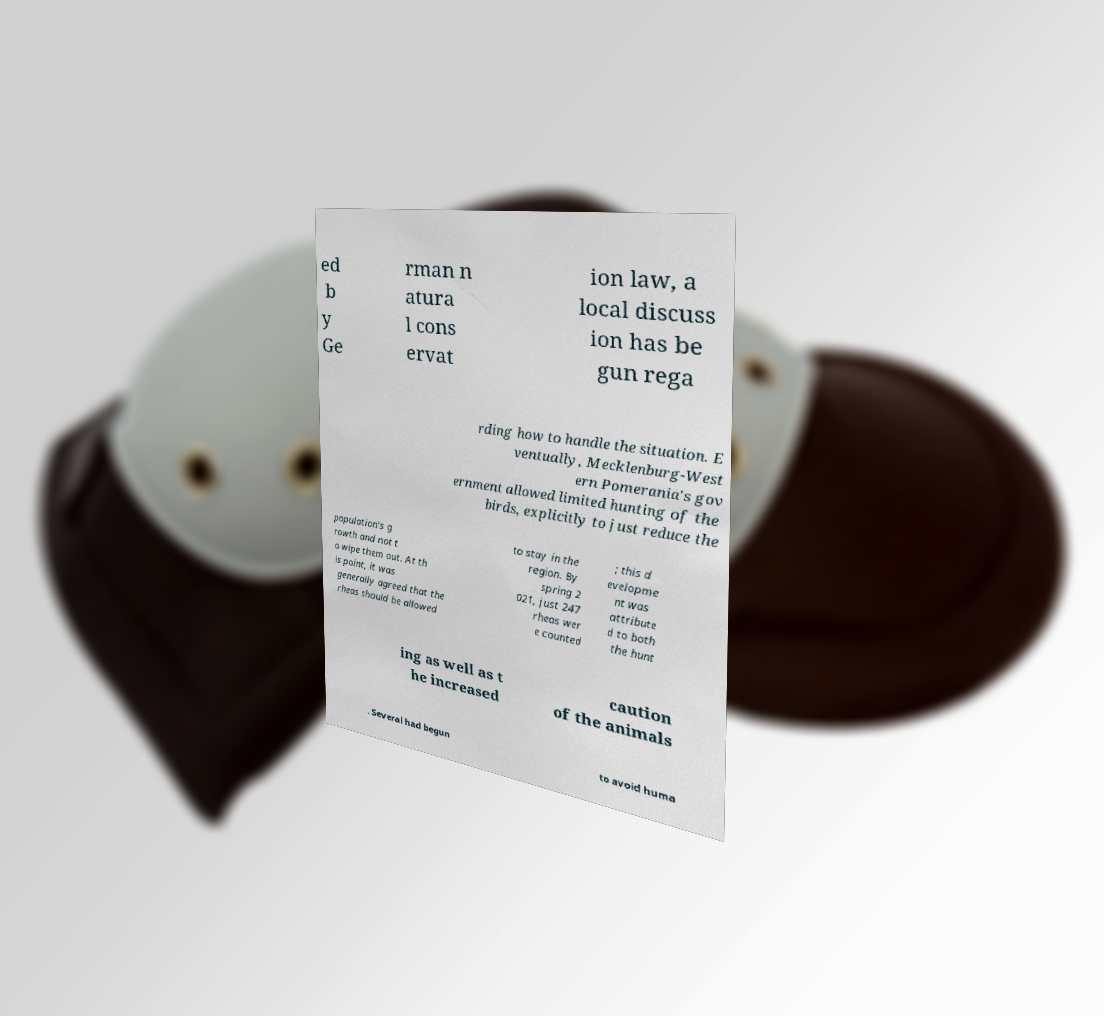There's text embedded in this image that I need extracted. Can you transcribe it verbatim? ed b y Ge rman n atura l cons ervat ion law, a local discuss ion has be gun rega rding how to handle the situation. E ventually, Mecklenburg-West ern Pomerania's gov ernment allowed limited hunting of the birds, explicitly to just reduce the population's g rowth and not t o wipe them out. At th is point, it was generally agreed that the rheas should be allowed to stay in the region. By spring 2 021, just 247 rheas wer e counted ; this d evelopme nt was attribute d to both the hunt ing as well as t he increased caution of the animals . Several had begun to avoid huma 